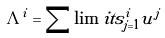Convert formula to latex. <formula><loc_0><loc_0><loc_500><loc_500>\Lambda ^ { i } = \sum \lim i t s _ { j = 1 } ^ { i } u ^ { j }</formula> 